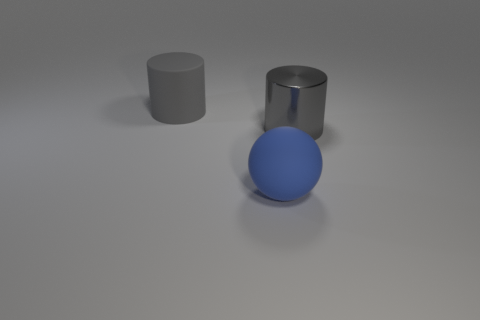Add 2 big cyan rubber cylinders. How many objects exist? 5 Subtract all spheres. How many objects are left? 2 Add 2 large blue matte balls. How many large blue matte balls exist? 3 Subtract 0 brown cylinders. How many objects are left? 3 Subtract all spheres. Subtract all big blue spheres. How many objects are left? 1 Add 1 large rubber cylinders. How many large rubber cylinders are left? 2 